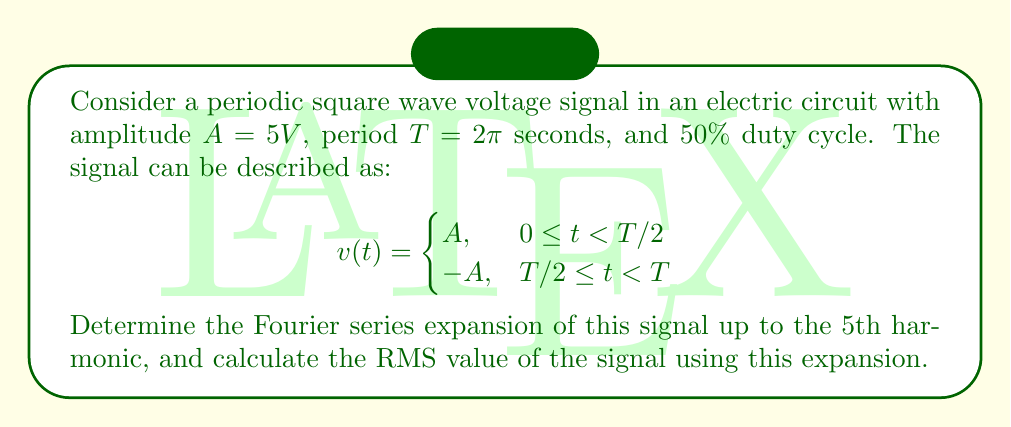Teach me how to tackle this problem. To solve this problem, we'll follow these steps:

1. Determine the Fourier series coefficients
2. Write the Fourier series expansion
3. Calculate the RMS value using the expansion

Step 1: Determine the Fourier series coefficients

For a periodic signal with period $T$, the Fourier series is given by:

$$
v(t) = a_0 + \sum_{n=1}^{\infty} \left(a_n \cos\left(\frac{2\pi n t}{T}\right) + b_n \sin\left(\frac{2\pi n t}{T}\right)\right)
$$

Where:
$$
a_0 = \frac{1}{T} \int_0^T v(t) dt
$$
$$
a_n = \frac{2}{T} \int_0^T v(t) \cos\left(\frac{2\pi n t}{T}\right) dt
$$
$$
b_n = \frac{2}{T} \int_0^T v(t) \sin\left(\frac{2\pi n t}{T}\right) dt
$$

For our square wave:

$a_0 = 0$ (because the positive and negative parts cancel out)

$a_n = 0$ (due to odd symmetry of the waveform)

$b_n = \frac{4A}{n\pi}$ for odd $n$, and 0 for even $n$

Step 2: Write the Fourier series expansion

Up to the 5th harmonic, the expansion is:

$$
v(t) = \frac{4A}{\pi} \sin\left(\frac{2\pi t}{T}\right) + \frac{4A}{3\pi} \sin\left(\frac{6\pi t}{T}\right) + \frac{4A}{5\pi} \sin\left(\frac{10\pi t}{T}\right)
$$

Substituting $A = 5V$ and $T = 2\pi$:

$$
v(t) = \frac{20}{\pi} \sin(t) + \frac{20}{3\pi} \sin(3t) + \frac{20}{5\pi} \sin(5t)
$$

Step 3: Calculate the RMS value

The RMS value of a periodic signal is given by:

$$
V_{RMS} = \sqrt{\frac{1}{T} \int_0^T v^2(t) dt}
$$

For a Fourier series, we can use Parseval's theorem, which states that:

$$
V_{RMS}^2 = a_0^2 + \frac{1}{2} \sum_{n=1}^{\infty} (a_n^2 + b_n^2)
$$

In our case, $a_0 = 0$ and $a_n = 0$, so:

$$
V_{RMS}^2 = \frac{1}{2} \sum_{n=1,3,5} \left(\frac{4A}{n\pi}\right)^2
$$

$$
V_{RMS}^2 = \frac{1}{2} \left[\left(\frac{4 \cdot 5}{\pi}\right)^2 + \left(\frac{4 \cdot 5}{3\pi}\right)^2 + \left(\frac{4 \cdot 5}{5\pi}\right)^2\right]
$$

$$
V_{RMS} = \sqrt{\frac{1}{2} \left[\left(\frac{20}{\pi}\right)^2 + \left(\frac{20}{3\pi}\right)^2 + \left(\frac{20}{5\pi}\right)^2\right]}
$$
Answer: The Fourier series expansion of the square wave up to the 5th harmonic is:

$$
v(t) = \frac{20}{\pi} \sin(t) + \frac{20}{3\pi} \sin(3t) + \frac{20}{5\pi} \sin(5t)
$$

The RMS value of the signal using this expansion is:

$$
V_{RMS} = \sqrt{\frac{1}{2} \left[\left(\frac{20}{\pi}\right)^2 + \left(\frac{20}{3\pi}\right)^2 + \left(\frac{20}{5\pi}\right)^2\right]} \approx 4.9572 V
$$ 